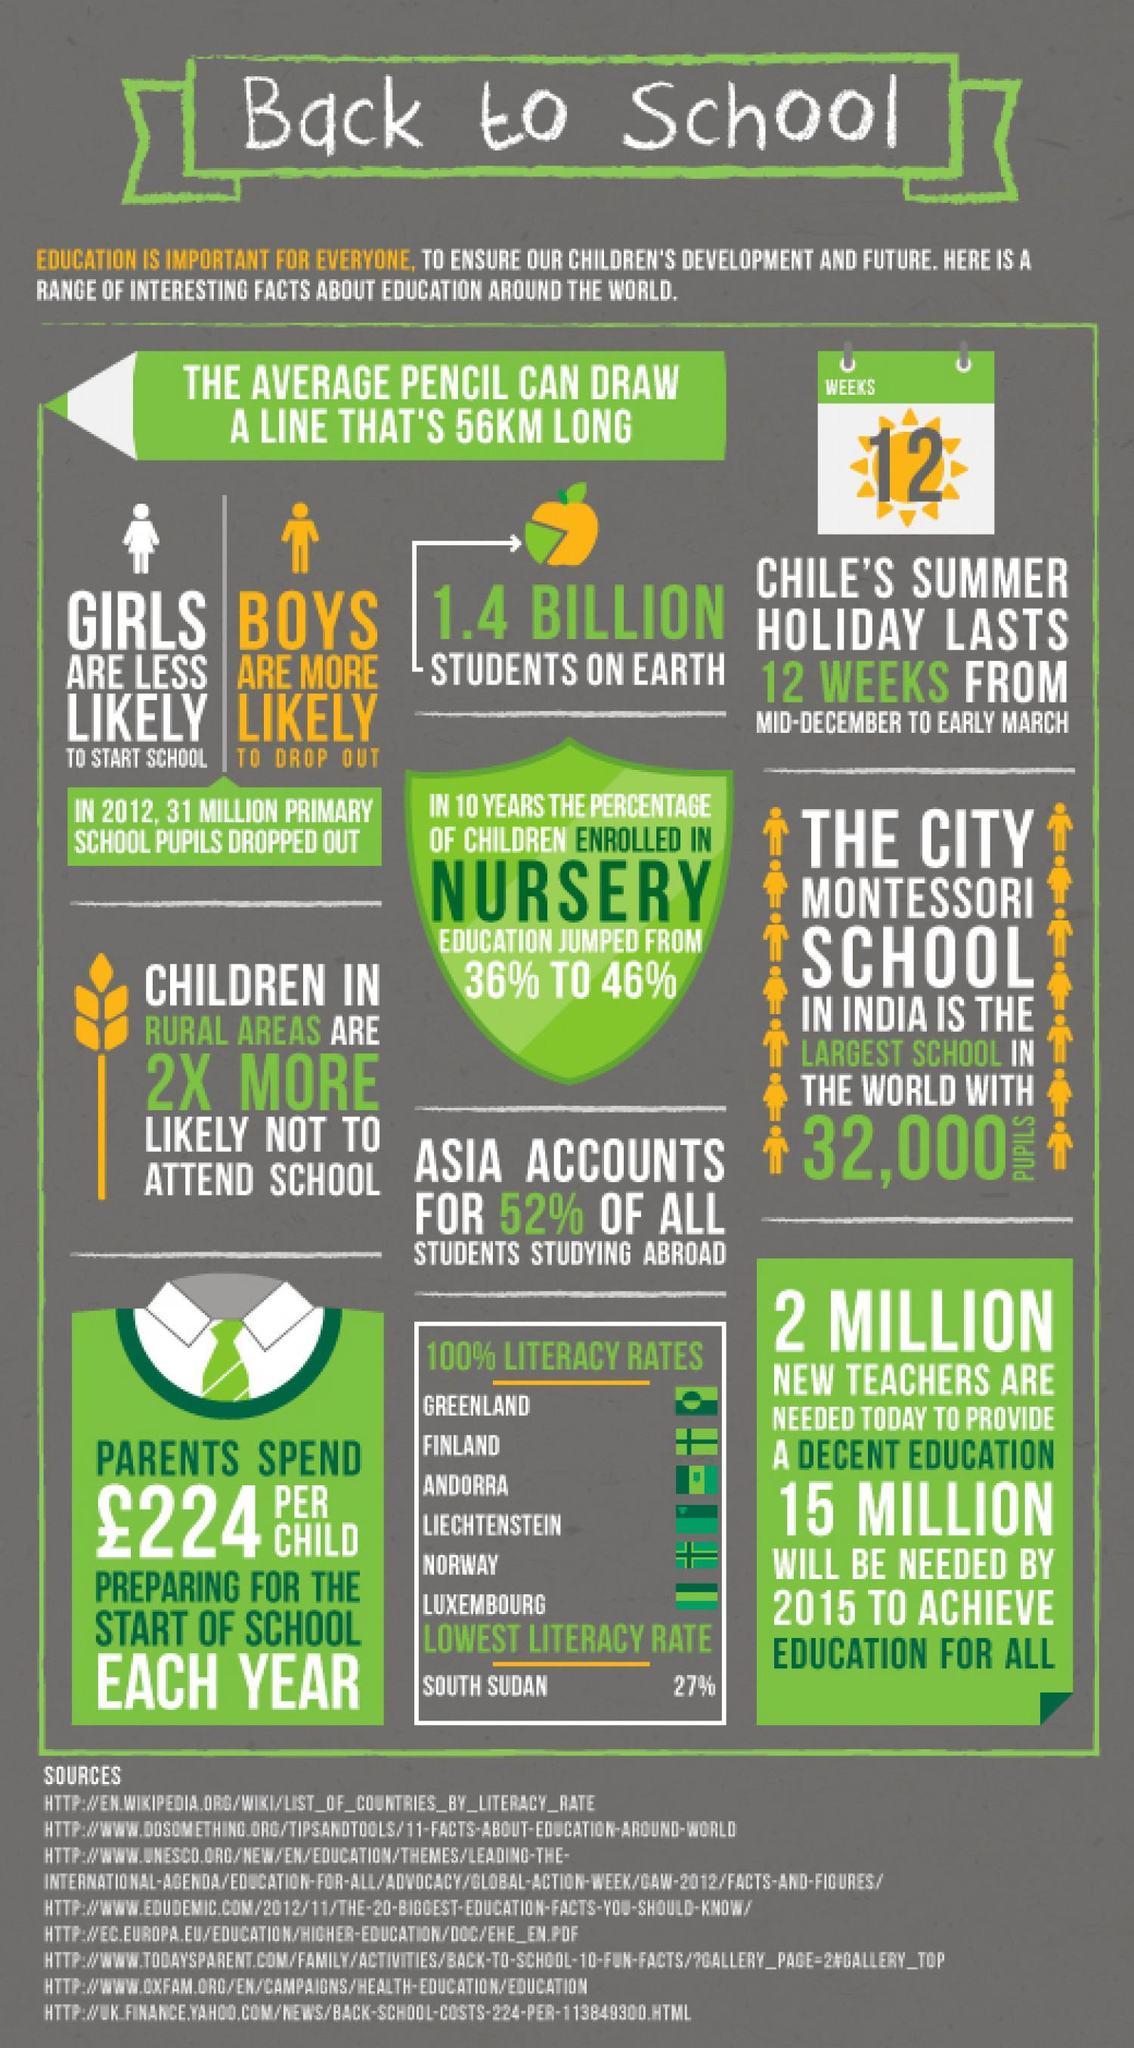How many pupils are there in the largest school in the world ?
Answer the question with a short phrase. 32,000 Which continent has the highest percentage of students studying abroad ? Asia Who are more likely to drop out - girls, boys or nursery students ? Boys What is the expenditure on each child for  beginning an academic year ? £ 224 Which region has lowest literacy rate ? South Sudan What is the total number of  students on earth ? 1.4 billion Which of the three countries has hundred percent literacy rate- Sudan, Norway or Chile ? Norway What is the percentage increase in the enrollment in nursery in the last decade ? 10% 